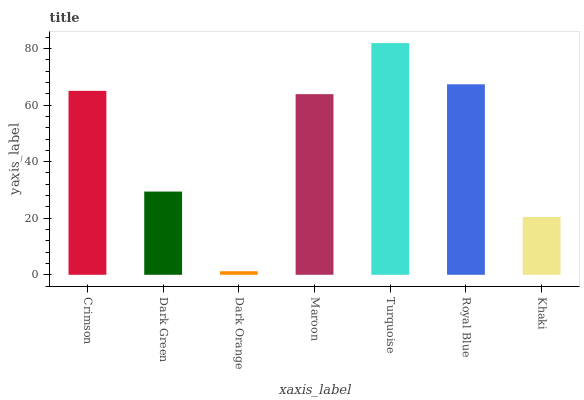Is Dark Orange the minimum?
Answer yes or no. Yes. Is Turquoise the maximum?
Answer yes or no. Yes. Is Dark Green the minimum?
Answer yes or no. No. Is Dark Green the maximum?
Answer yes or no. No. Is Crimson greater than Dark Green?
Answer yes or no. Yes. Is Dark Green less than Crimson?
Answer yes or no. Yes. Is Dark Green greater than Crimson?
Answer yes or no. No. Is Crimson less than Dark Green?
Answer yes or no. No. Is Maroon the high median?
Answer yes or no. Yes. Is Maroon the low median?
Answer yes or no. Yes. Is Dark Orange the high median?
Answer yes or no. No. Is Dark Green the low median?
Answer yes or no. No. 